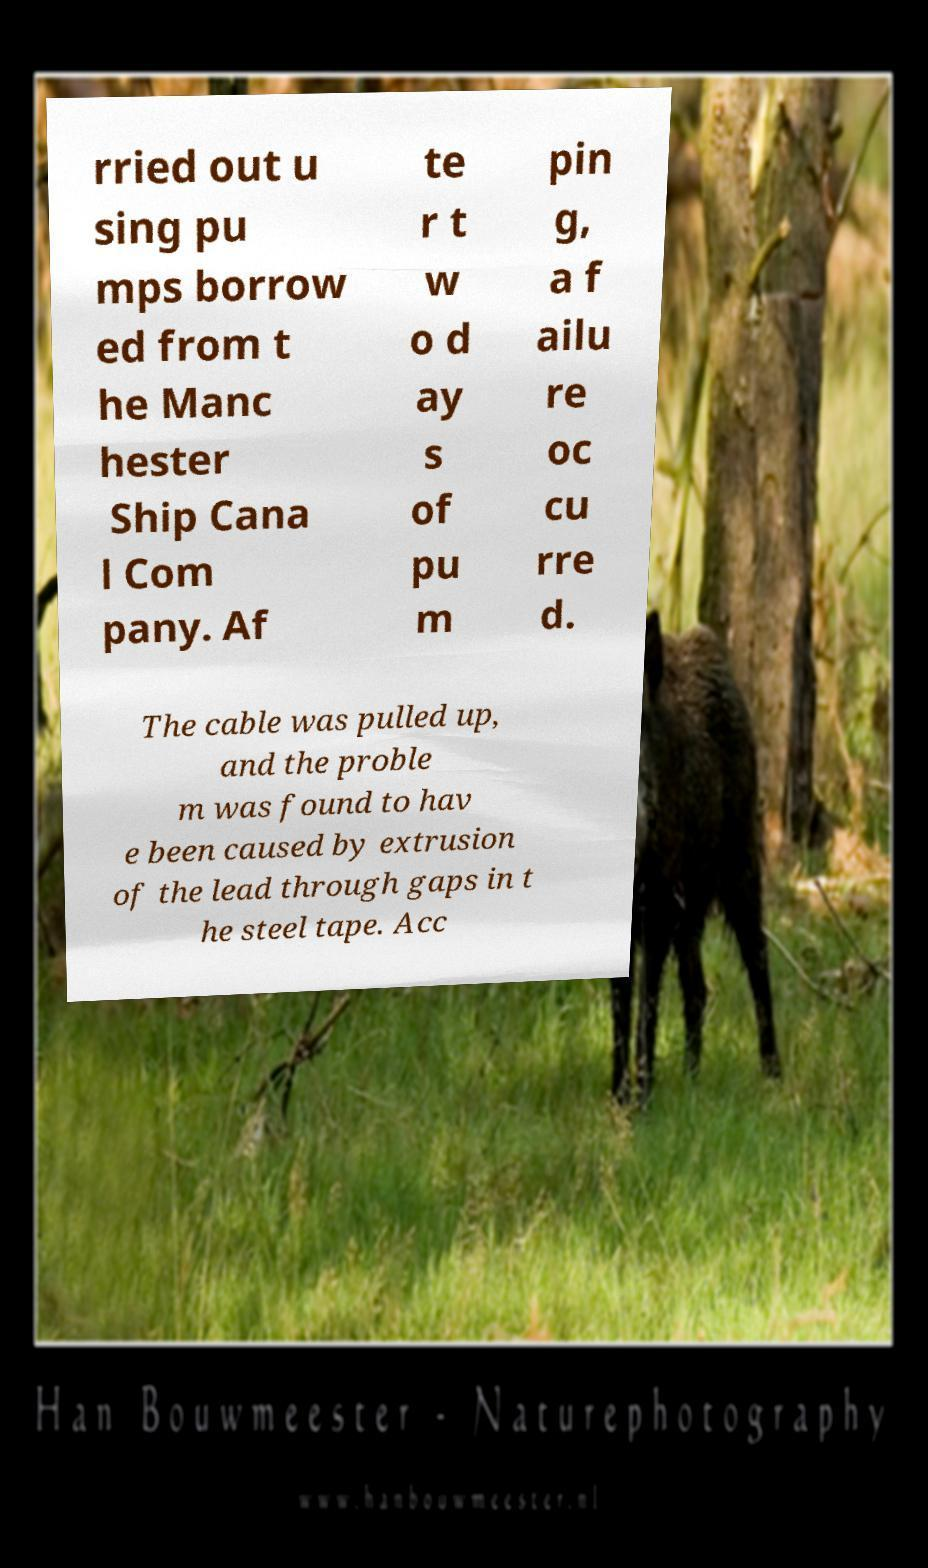Can you accurately transcribe the text from the provided image for me? rried out u sing pu mps borrow ed from t he Manc hester Ship Cana l Com pany. Af te r t w o d ay s of pu m pin g, a f ailu re oc cu rre d. The cable was pulled up, and the proble m was found to hav e been caused by extrusion of the lead through gaps in t he steel tape. Acc 